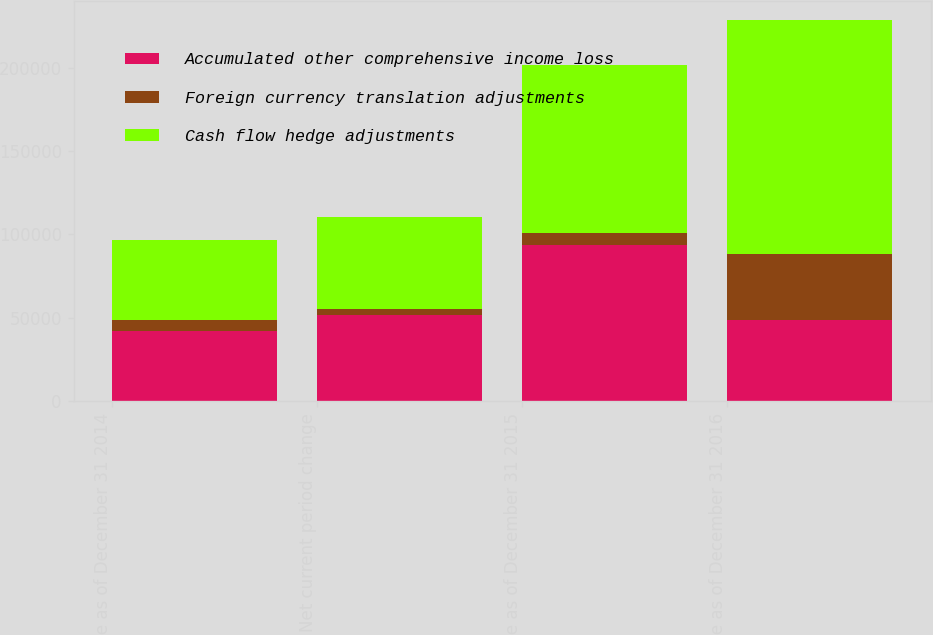<chart> <loc_0><loc_0><loc_500><loc_500><stacked_bar_chart><ecel><fcel>Balance as of December 31 2014<fcel>Net current period change<fcel>Balance as of December 31 2015<fcel>Balance as of December 31 2016<nl><fcel>Accumulated other comprehensive income loss<fcel>42138<fcel>51745<fcel>93883<fcel>48433<nl><fcel>Foreign currency translation adjustments<fcel>6295<fcel>3407<fcel>7081<fcel>39885<nl><fcel>Cash flow hedge adjustments<fcel>48433<fcel>55152<fcel>100964<fcel>140619<nl></chart> 